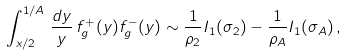Convert formula to latex. <formula><loc_0><loc_0><loc_500><loc_500>\int ^ { 1 / A } _ { x / 2 } \, \frac { d y } { y } \, f ^ { + } _ { g } ( y ) f ^ { - } _ { g } ( y ) \sim \frac { 1 } { \rho _ { 2 } } I _ { 1 } ( \sigma _ { 2 } ) - \frac { 1 } { \rho _ { A } } I _ { 1 } ( \sigma _ { A } ) \, ,</formula> 